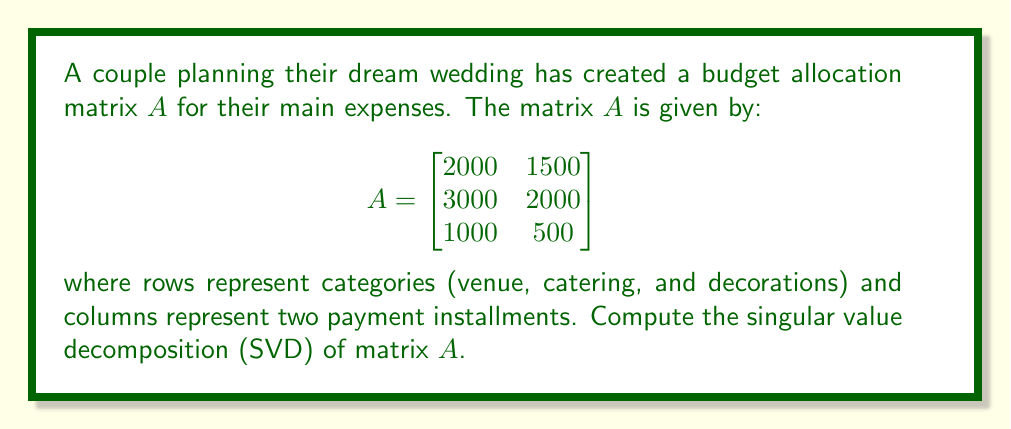Can you solve this math problem? To find the singular value decomposition of matrix $A$, we need to determine matrices $U$, $\Sigma$, and $V^T$ such that $A = U\Sigma V^T$.

Step 1: Calculate $A^TA$ and $AA^T$
$$A^TA = \begin{bmatrix}
2000 & 3000 & 1000 \\
1500 & 2000 & 500
\end{bmatrix} \begin{bmatrix}
2000 & 1500 \\
3000 & 2000 \\
1000 & 500
\end{bmatrix} = \begin{bmatrix}
14000000 & 9500000 \\
9500000 & 6500000
\end{bmatrix}$$

$$AA^T = \begin{bmatrix}
2000 & 1500 \\
3000 & 2000 \\
1000 & 500
\end{bmatrix} \begin{bmatrix}
2000 & 3000 & 1000 \\
1500 & 2000 & 500
\end{bmatrix} = \begin{bmatrix}
6250000 & 9000000 & 3000000 \\
9000000 & 13000000 & 4250000 \\
3000000 & 4250000 & 1250000
\end{bmatrix}$$

Step 2: Find eigenvalues of $A^TA$ (which are the squares of singular values)
Characteristic equation: $\det(A^TA - \lambda I) = 0$
$$(14000000 - \lambda)(6500000 - \lambda) - 9500000^2 = 0$$
$$\lambda^2 - 20500000\lambda + 1500000000 = 0$$
Solving this, we get:
$\lambda_1 = 20146446.65$ and $\lambda_2 = 353553.35$

Step 3: Calculate singular values
$\sigma_1 = \sqrt{20146446.65} \approx 4487.37$
$\sigma_2 = \sqrt{353553.35} \approx 594.60$

Step 4: Find eigenvectors of $A^TA$ to get columns of $V$
For $\lambda_1$:
$$(A^TA - \lambda_1 I)v_1 = 0$$
Solving this, we get $v_1 \approx [0.8295, 0.5585]^T$

For $\lambda_2$:
$$(A^TA - \lambda_2 I)v_2 = 0$$
Solving this, we get $v_2 \approx [-0.5585, 0.8295]^T$

Step 5: Find eigenvectors of $AA^T$ to get columns of $U$
For $\lambda_1$:
$$(AA^T - \lambda_1 I)u_1 = 0$$
Solving this, we get $u_1 \approx [0.4446, 0.6402, 0.6268]^T$

For $\lambda_2$:
$$(AA^T - \lambda_2 I)u_2 = 0$$
Solving this, we get $u_2 \approx [-0.7746, 0.0908, 0.6259]^T$

The third column of $U$ can be found by taking the cross product of $u_1$ and $u_2$:
$u_3 \approx [0.4498, -0.7631, 0.4634]^T$

Step 6: Construct matrices $U$, $\Sigma$, and $V^T$
$$U \approx \begin{bmatrix}
0.4446 & -0.7746 & 0.4498 \\
0.6402 & 0.0908 & -0.7631 \\
0.6268 & 0.6259 & 0.4634
\end{bmatrix}$$

$$\Sigma \approx \begin{bmatrix}
4487.37 & 0 \\
0 & 594.60 \\
0 & 0
\end{bmatrix}$$

$$V^T \approx \begin{bmatrix}
0.8295 & 0.5585 \\
-0.5585 & 0.8295
\end{bmatrix}$$
Answer: $A = U\Sigma V^T$, where:
$U \approx \begin{bmatrix}
0.4446 & -0.7746 & 0.4498 \\
0.6402 & 0.0908 & -0.7631 \\
0.6268 & 0.6259 & 0.4634
\end{bmatrix}$,
$\Sigma \approx \begin{bmatrix}
4487.37 & 0 \\
0 & 594.60 \\
0 & 0
\end{bmatrix}$,
$V^T \approx \begin{bmatrix}
0.8295 & 0.5585 \\
-0.5585 & 0.8295
\end{bmatrix}$ 